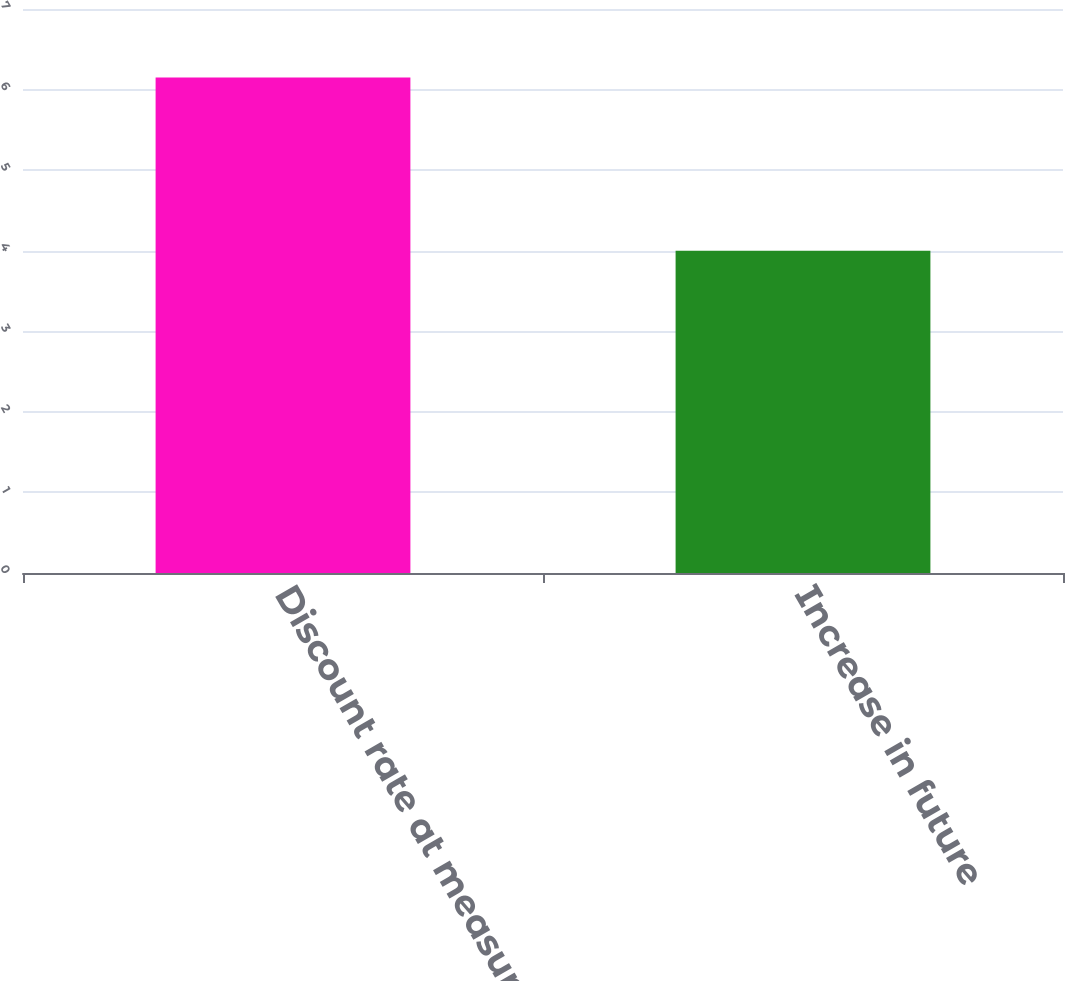Convert chart to OTSL. <chart><loc_0><loc_0><loc_500><loc_500><bar_chart><fcel>Discount rate at measurement<fcel>Increase in future<nl><fcel>6.15<fcel>4<nl></chart> 